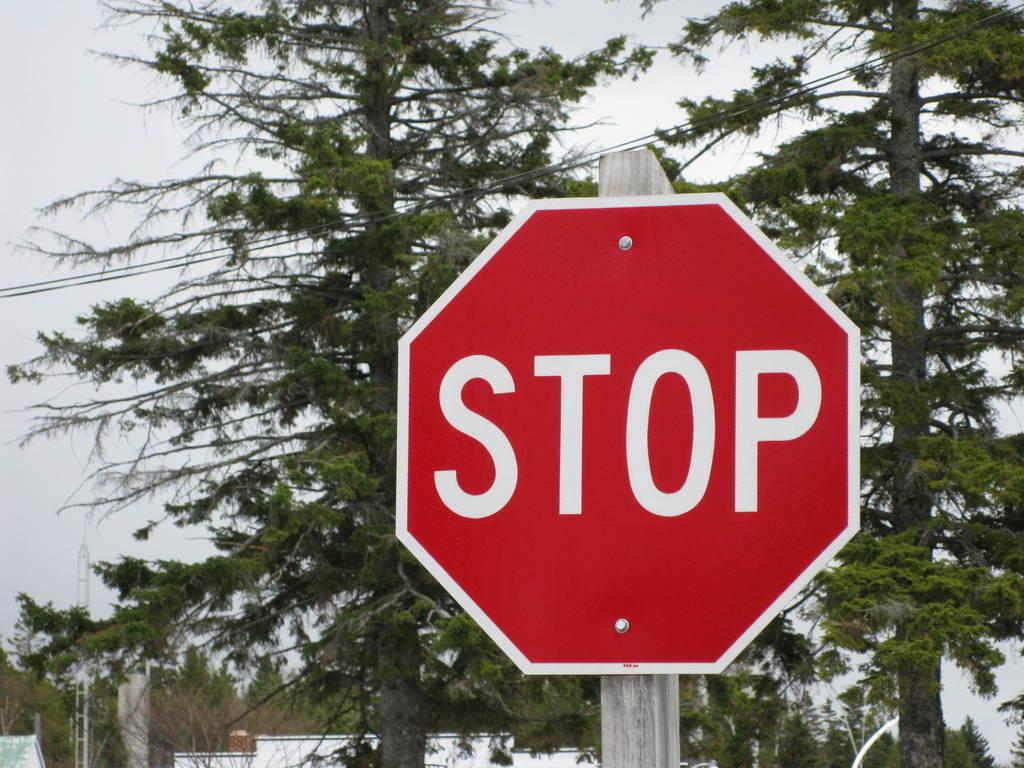<image>
Describe the image concisely. a stop sign that is around some trees 